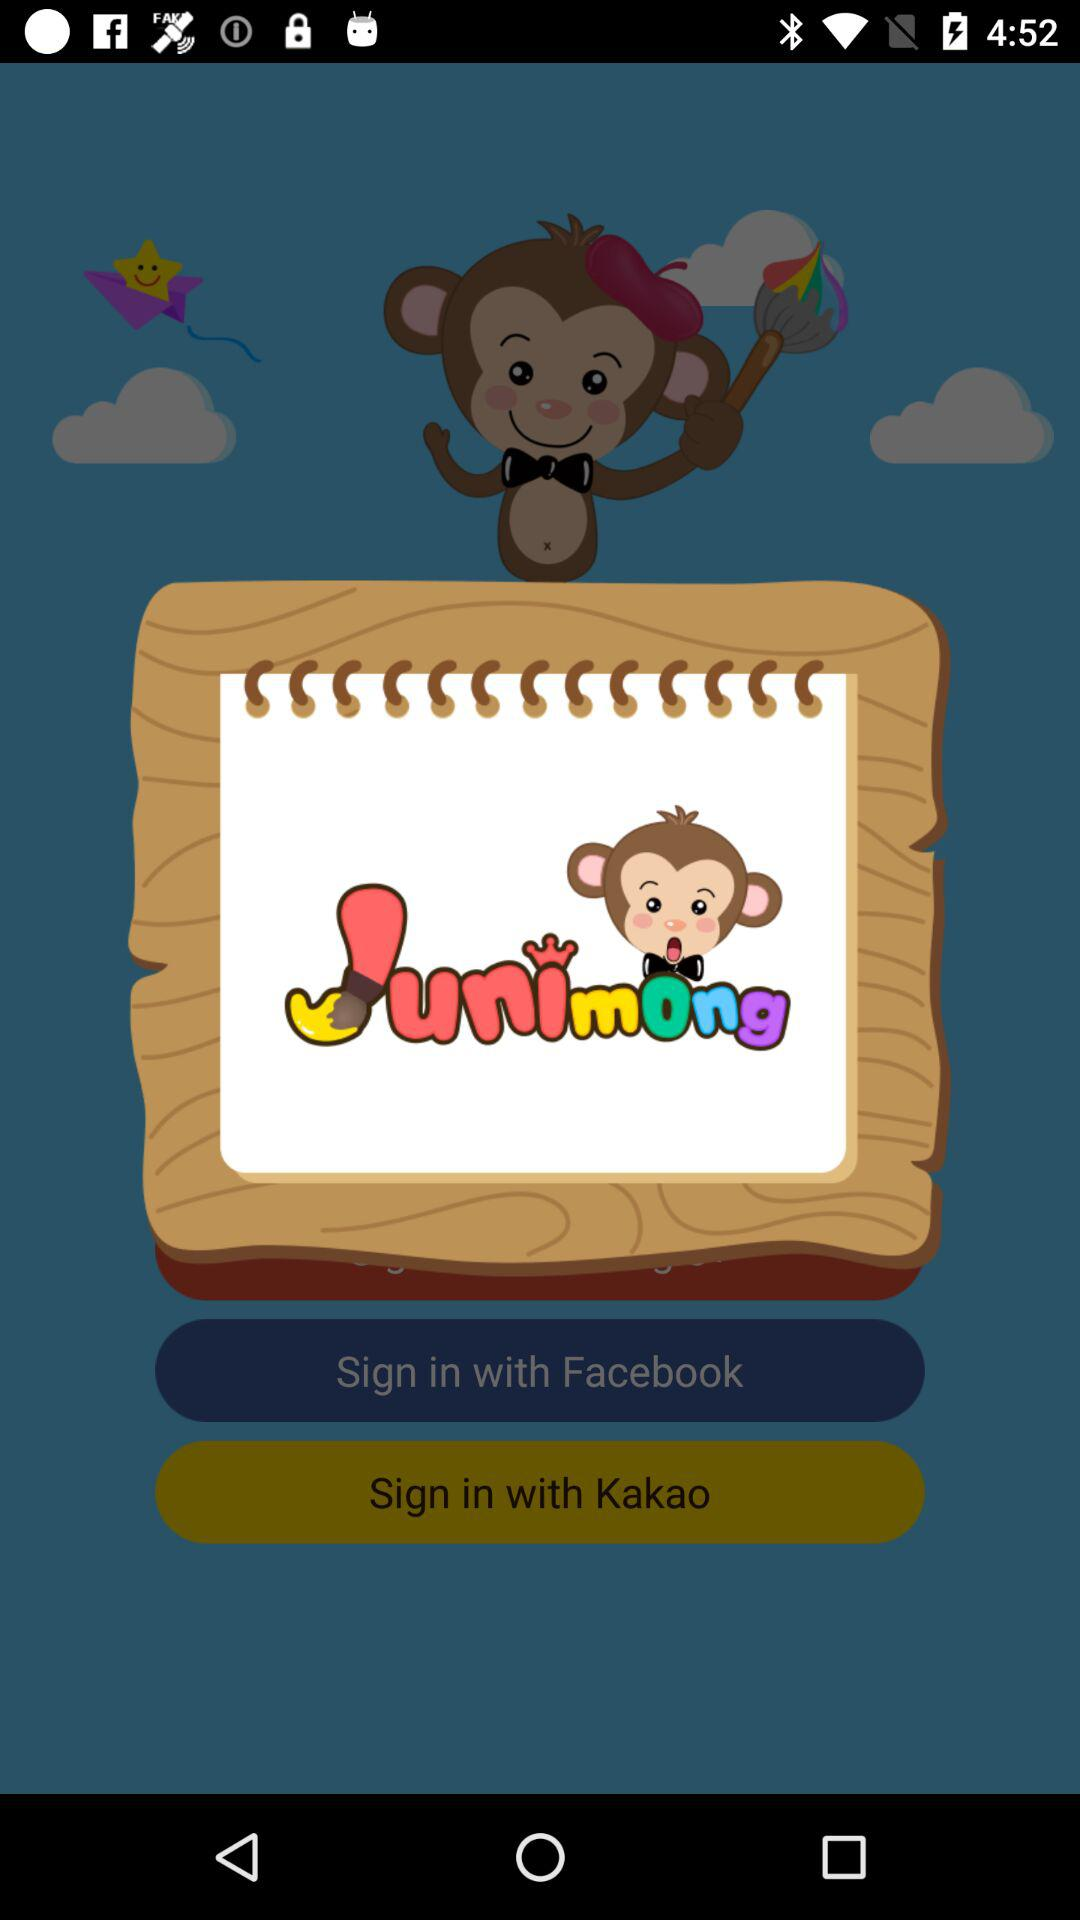What accounts can I use to sign in? You can sign in with "Accounts", "Google+", "Facebook" and "Kakao". 